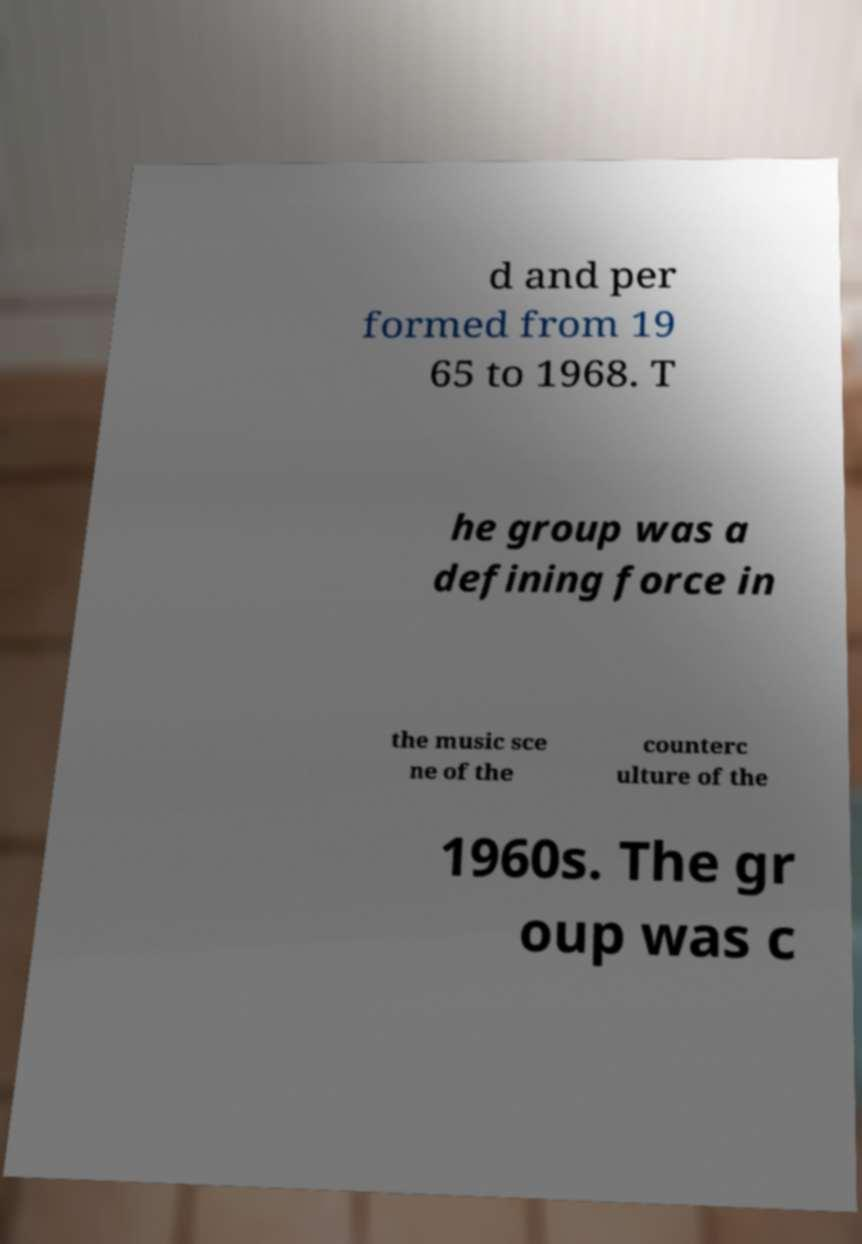Could you extract and type out the text from this image? d and per formed from 19 65 to 1968. T he group was a defining force in the music sce ne of the counterc ulture of the 1960s. The gr oup was c 